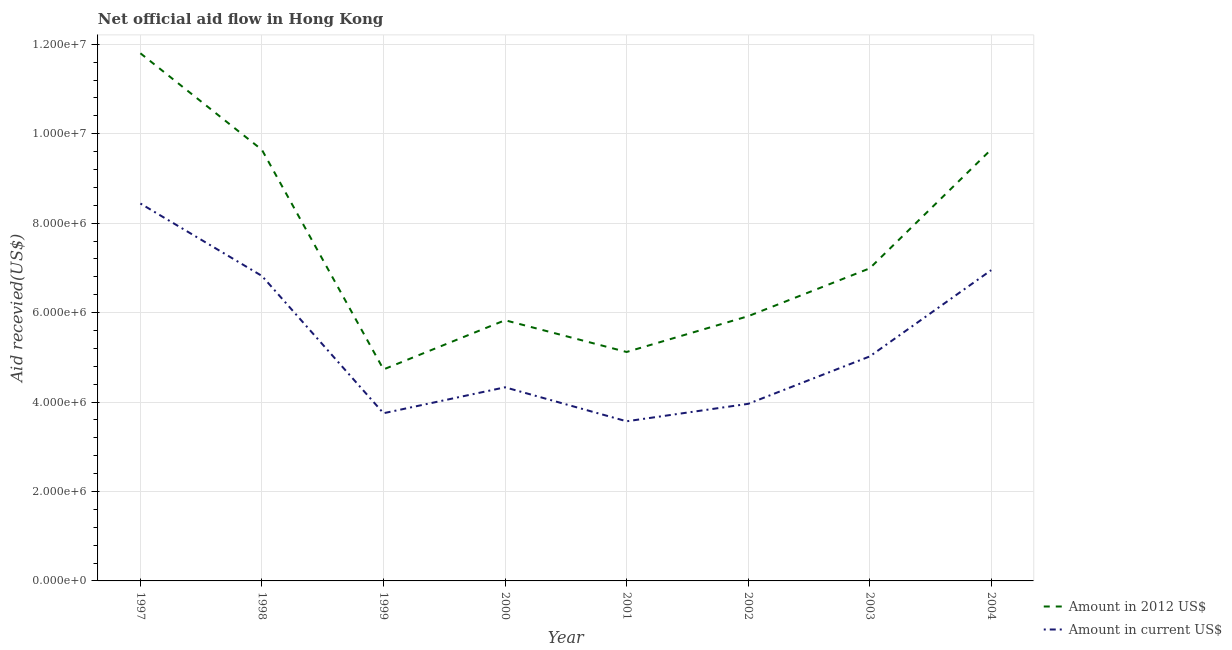What is the amount of aid received(expressed in 2012 us$) in 1998?
Your answer should be compact. 9.64e+06. Across all years, what is the maximum amount of aid received(expressed in 2012 us$)?
Your answer should be very brief. 1.18e+07. Across all years, what is the minimum amount of aid received(expressed in us$)?
Give a very brief answer. 3.57e+06. In which year was the amount of aid received(expressed in us$) maximum?
Your answer should be very brief. 1997. In which year was the amount of aid received(expressed in us$) minimum?
Provide a succinct answer. 2001. What is the total amount of aid received(expressed in 2012 us$) in the graph?
Ensure brevity in your answer.  5.97e+07. What is the difference between the amount of aid received(expressed in 2012 us$) in 1997 and that in 2002?
Keep it short and to the point. 5.88e+06. What is the difference between the amount of aid received(expressed in 2012 us$) in 1999 and the amount of aid received(expressed in us$) in 2002?
Keep it short and to the point. 7.70e+05. What is the average amount of aid received(expressed in 2012 us$) per year?
Ensure brevity in your answer.  7.46e+06. In the year 1999, what is the difference between the amount of aid received(expressed in us$) and amount of aid received(expressed in 2012 us$)?
Make the answer very short. -9.80e+05. In how many years, is the amount of aid received(expressed in us$) greater than 11600000 US$?
Make the answer very short. 0. What is the ratio of the amount of aid received(expressed in 2012 us$) in 2001 to that in 2003?
Provide a succinct answer. 0.73. Is the amount of aid received(expressed in us$) in 2001 less than that in 2002?
Your answer should be very brief. Yes. What is the difference between the highest and the second highest amount of aid received(expressed in 2012 us$)?
Your answer should be compact. 2.15e+06. What is the difference between the highest and the lowest amount of aid received(expressed in us$)?
Offer a terse response. 4.87e+06. Is the sum of the amount of aid received(expressed in us$) in 1997 and 2003 greater than the maximum amount of aid received(expressed in 2012 us$) across all years?
Your answer should be very brief. Yes. Does the amount of aid received(expressed in us$) monotonically increase over the years?
Keep it short and to the point. No. Is the amount of aid received(expressed in 2012 us$) strictly less than the amount of aid received(expressed in us$) over the years?
Offer a terse response. No. How many lines are there?
Give a very brief answer. 2. Are the values on the major ticks of Y-axis written in scientific E-notation?
Make the answer very short. Yes. Does the graph contain any zero values?
Provide a short and direct response. No. What is the title of the graph?
Offer a very short reply. Net official aid flow in Hong Kong. Does "Travel Items" appear as one of the legend labels in the graph?
Keep it short and to the point. No. What is the label or title of the Y-axis?
Offer a very short reply. Aid recevied(US$). What is the Aid recevied(US$) in Amount in 2012 US$ in 1997?
Ensure brevity in your answer.  1.18e+07. What is the Aid recevied(US$) of Amount in current US$ in 1997?
Offer a very short reply. 8.44e+06. What is the Aid recevied(US$) in Amount in 2012 US$ in 1998?
Make the answer very short. 9.64e+06. What is the Aid recevied(US$) in Amount in current US$ in 1998?
Your answer should be very brief. 6.82e+06. What is the Aid recevied(US$) in Amount in 2012 US$ in 1999?
Keep it short and to the point. 4.73e+06. What is the Aid recevied(US$) of Amount in current US$ in 1999?
Ensure brevity in your answer.  3.75e+06. What is the Aid recevied(US$) of Amount in 2012 US$ in 2000?
Your answer should be very brief. 5.83e+06. What is the Aid recevied(US$) in Amount in current US$ in 2000?
Ensure brevity in your answer.  4.33e+06. What is the Aid recevied(US$) in Amount in 2012 US$ in 2001?
Your answer should be very brief. 5.12e+06. What is the Aid recevied(US$) of Amount in current US$ in 2001?
Provide a short and direct response. 3.57e+06. What is the Aid recevied(US$) in Amount in 2012 US$ in 2002?
Your response must be concise. 5.92e+06. What is the Aid recevied(US$) of Amount in current US$ in 2002?
Ensure brevity in your answer.  3.96e+06. What is the Aid recevied(US$) in Amount in 2012 US$ in 2003?
Your response must be concise. 6.99e+06. What is the Aid recevied(US$) in Amount in current US$ in 2003?
Offer a terse response. 5.02e+06. What is the Aid recevied(US$) in Amount in 2012 US$ in 2004?
Keep it short and to the point. 9.65e+06. What is the Aid recevied(US$) in Amount in current US$ in 2004?
Offer a very short reply. 6.95e+06. Across all years, what is the maximum Aid recevied(US$) of Amount in 2012 US$?
Make the answer very short. 1.18e+07. Across all years, what is the maximum Aid recevied(US$) of Amount in current US$?
Give a very brief answer. 8.44e+06. Across all years, what is the minimum Aid recevied(US$) in Amount in 2012 US$?
Keep it short and to the point. 4.73e+06. Across all years, what is the minimum Aid recevied(US$) in Amount in current US$?
Make the answer very short. 3.57e+06. What is the total Aid recevied(US$) of Amount in 2012 US$ in the graph?
Keep it short and to the point. 5.97e+07. What is the total Aid recevied(US$) in Amount in current US$ in the graph?
Offer a very short reply. 4.28e+07. What is the difference between the Aid recevied(US$) of Amount in 2012 US$ in 1997 and that in 1998?
Your answer should be very brief. 2.16e+06. What is the difference between the Aid recevied(US$) in Amount in current US$ in 1997 and that in 1998?
Keep it short and to the point. 1.62e+06. What is the difference between the Aid recevied(US$) of Amount in 2012 US$ in 1997 and that in 1999?
Keep it short and to the point. 7.07e+06. What is the difference between the Aid recevied(US$) in Amount in current US$ in 1997 and that in 1999?
Your answer should be very brief. 4.69e+06. What is the difference between the Aid recevied(US$) in Amount in 2012 US$ in 1997 and that in 2000?
Provide a short and direct response. 5.97e+06. What is the difference between the Aid recevied(US$) in Amount in current US$ in 1997 and that in 2000?
Provide a succinct answer. 4.11e+06. What is the difference between the Aid recevied(US$) in Amount in 2012 US$ in 1997 and that in 2001?
Make the answer very short. 6.68e+06. What is the difference between the Aid recevied(US$) of Amount in current US$ in 1997 and that in 2001?
Your answer should be compact. 4.87e+06. What is the difference between the Aid recevied(US$) in Amount in 2012 US$ in 1997 and that in 2002?
Your answer should be very brief. 5.88e+06. What is the difference between the Aid recevied(US$) in Amount in current US$ in 1997 and that in 2002?
Your answer should be compact. 4.48e+06. What is the difference between the Aid recevied(US$) of Amount in 2012 US$ in 1997 and that in 2003?
Offer a terse response. 4.81e+06. What is the difference between the Aid recevied(US$) of Amount in current US$ in 1997 and that in 2003?
Make the answer very short. 3.42e+06. What is the difference between the Aid recevied(US$) in Amount in 2012 US$ in 1997 and that in 2004?
Make the answer very short. 2.15e+06. What is the difference between the Aid recevied(US$) in Amount in current US$ in 1997 and that in 2004?
Make the answer very short. 1.49e+06. What is the difference between the Aid recevied(US$) in Amount in 2012 US$ in 1998 and that in 1999?
Keep it short and to the point. 4.91e+06. What is the difference between the Aid recevied(US$) of Amount in current US$ in 1998 and that in 1999?
Make the answer very short. 3.07e+06. What is the difference between the Aid recevied(US$) in Amount in 2012 US$ in 1998 and that in 2000?
Give a very brief answer. 3.81e+06. What is the difference between the Aid recevied(US$) in Amount in current US$ in 1998 and that in 2000?
Your response must be concise. 2.49e+06. What is the difference between the Aid recevied(US$) in Amount in 2012 US$ in 1998 and that in 2001?
Keep it short and to the point. 4.52e+06. What is the difference between the Aid recevied(US$) in Amount in current US$ in 1998 and that in 2001?
Provide a succinct answer. 3.25e+06. What is the difference between the Aid recevied(US$) of Amount in 2012 US$ in 1998 and that in 2002?
Provide a succinct answer. 3.72e+06. What is the difference between the Aid recevied(US$) in Amount in current US$ in 1998 and that in 2002?
Your response must be concise. 2.86e+06. What is the difference between the Aid recevied(US$) of Amount in 2012 US$ in 1998 and that in 2003?
Offer a terse response. 2.65e+06. What is the difference between the Aid recevied(US$) of Amount in current US$ in 1998 and that in 2003?
Offer a terse response. 1.80e+06. What is the difference between the Aid recevied(US$) of Amount in 2012 US$ in 1999 and that in 2000?
Your answer should be very brief. -1.10e+06. What is the difference between the Aid recevied(US$) in Amount in current US$ in 1999 and that in 2000?
Your answer should be very brief. -5.80e+05. What is the difference between the Aid recevied(US$) in Amount in 2012 US$ in 1999 and that in 2001?
Offer a terse response. -3.90e+05. What is the difference between the Aid recevied(US$) in Amount in 2012 US$ in 1999 and that in 2002?
Make the answer very short. -1.19e+06. What is the difference between the Aid recevied(US$) in Amount in current US$ in 1999 and that in 2002?
Give a very brief answer. -2.10e+05. What is the difference between the Aid recevied(US$) of Amount in 2012 US$ in 1999 and that in 2003?
Keep it short and to the point. -2.26e+06. What is the difference between the Aid recevied(US$) in Amount in current US$ in 1999 and that in 2003?
Your response must be concise. -1.27e+06. What is the difference between the Aid recevied(US$) in Amount in 2012 US$ in 1999 and that in 2004?
Offer a terse response. -4.92e+06. What is the difference between the Aid recevied(US$) in Amount in current US$ in 1999 and that in 2004?
Give a very brief answer. -3.20e+06. What is the difference between the Aid recevied(US$) in Amount in 2012 US$ in 2000 and that in 2001?
Offer a very short reply. 7.10e+05. What is the difference between the Aid recevied(US$) in Amount in current US$ in 2000 and that in 2001?
Ensure brevity in your answer.  7.60e+05. What is the difference between the Aid recevied(US$) in Amount in 2012 US$ in 2000 and that in 2002?
Ensure brevity in your answer.  -9.00e+04. What is the difference between the Aid recevied(US$) of Amount in current US$ in 2000 and that in 2002?
Offer a very short reply. 3.70e+05. What is the difference between the Aid recevied(US$) of Amount in 2012 US$ in 2000 and that in 2003?
Provide a short and direct response. -1.16e+06. What is the difference between the Aid recevied(US$) of Amount in current US$ in 2000 and that in 2003?
Your answer should be compact. -6.90e+05. What is the difference between the Aid recevied(US$) of Amount in 2012 US$ in 2000 and that in 2004?
Your answer should be compact. -3.82e+06. What is the difference between the Aid recevied(US$) of Amount in current US$ in 2000 and that in 2004?
Offer a very short reply. -2.62e+06. What is the difference between the Aid recevied(US$) in Amount in 2012 US$ in 2001 and that in 2002?
Make the answer very short. -8.00e+05. What is the difference between the Aid recevied(US$) of Amount in current US$ in 2001 and that in 2002?
Ensure brevity in your answer.  -3.90e+05. What is the difference between the Aid recevied(US$) of Amount in 2012 US$ in 2001 and that in 2003?
Your answer should be compact. -1.87e+06. What is the difference between the Aid recevied(US$) of Amount in current US$ in 2001 and that in 2003?
Your answer should be compact. -1.45e+06. What is the difference between the Aid recevied(US$) in Amount in 2012 US$ in 2001 and that in 2004?
Your answer should be very brief. -4.53e+06. What is the difference between the Aid recevied(US$) in Amount in current US$ in 2001 and that in 2004?
Make the answer very short. -3.38e+06. What is the difference between the Aid recevied(US$) of Amount in 2012 US$ in 2002 and that in 2003?
Offer a terse response. -1.07e+06. What is the difference between the Aid recevied(US$) in Amount in current US$ in 2002 and that in 2003?
Your answer should be compact. -1.06e+06. What is the difference between the Aid recevied(US$) of Amount in 2012 US$ in 2002 and that in 2004?
Keep it short and to the point. -3.73e+06. What is the difference between the Aid recevied(US$) of Amount in current US$ in 2002 and that in 2004?
Offer a very short reply. -2.99e+06. What is the difference between the Aid recevied(US$) of Amount in 2012 US$ in 2003 and that in 2004?
Ensure brevity in your answer.  -2.66e+06. What is the difference between the Aid recevied(US$) in Amount in current US$ in 2003 and that in 2004?
Your answer should be compact. -1.93e+06. What is the difference between the Aid recevied(US$) of Amount in 2012 US$ in 1997 and the Aid recevied(US$) of Amount in current US$ in 1998?
Offer a very short reply. 4.98e+06. What is the difference between the Aid recevied(US$) in Amount in 2012 US$ in 1997 and the Aid recevied(US$) in Amount in current US$ in 1999?
Provide a short and direct response. 8.05e+06. What is the difference between the Aid recevied(US$) of Amount in 2012 US$ in 1997 and the Aid recevied(US$) of Amount in current US$ in 2000?
Make the answer very short. 7.47e+06. What is the difference between the Aid recevied(US$) in Amount in 2012 US$ in 1997 and the Aid recevied(US$) in Amount in current US$ in 2001?
Offer a very short reply. 8.23e+06. What is the difference between the Aid recevied(US$) of Amount in 2012 US$ in 1997 and the Aid recevied(US$) of Amount in current US$ in 2002?
Ensure brevity in your answer.  7.84e+06. What is the difference between the Aid recevied(US$) of Amount in 2012 US$ in 1997 and the Aid recevied(US$) of Amount in current US$ in 2003?
Your answer should be compact. 6.78e+06. What is the difference between the Aid recevied(US$) of Amount in 2012 US$ in 1997 and the Aid recevied(US$) of Amount in current US$ in 2004?
Ensure brevity in your answer.  4.85e+06. What is the difference between the Aid recevied(US$) of Amount in 2012 US$ in 1998 and the Aid recevied(US$) of Amount in current US$ in 1999?
Keep it short and to the point. 5.89e+06. What is the difference between the Aid recevied(US$) in Amount in 2012 US$ in 1998 and the Aid recevied(US$) in Amount in current US$ in 2000?
Your answer should be very brief. 5.31e+06. What is the difference between the Aid recevied(US$) of Amount in 2012 US$ in 1998 and the Aid recevied(US$) of Amount in current US$ in 2001?
Offer a very short reply. 6.07e+06. What is the difference between the Aid recevied(US$) of Amount in 2012 US$ in 1998 and the Aid recevied(US$) of Amount in current US$ in 2002?
Provide a succinct answer. 5.68e+06. What is the difference between the Aid recevied(US$) of Amount in 2012 US$ in 1998 and the Aid recevied(US$) of Amount in current US$ in 2003?
Give a very brief answer. 4.62e+06. What is the difference between the Aid recevied(US$) of Amount in 2012 US$ in 1998 and the Aid recevied(US$) of Amount in current US$ in 2004?
Provide a short and direct response. 2.69e+06. What is the difference between the Aid recevied(US$) in Amount in 2012 US$ in 1999 and the Aid recevied(US$) in Amount in current US$ in 2001?
Make the answer very short. 1.16e+06. What is the difference between the Aid recevied(US$) of Amount in 2012 US$ in 1999 and the Aid recevied(US$) of Amount in current US$ in 2002?
Provide a succinct answer. 7.70e+05. What is the difference between the Aid recevied(US$) of Amount in 2012 US$ in 1999 and the Aid recevied(US$) of Amount in current US$ in 2003?
Your answer should be compact. -2.90e+05. What is the difference between the Aid recevied(US$) of Amount in 2012 US$ in 1999 and the Aid recevied(US$) of Amount in current US$ in 2004?
Your answer should be very brief. -2.22e+06. What is the difference between the Aid recevied(US$) in Amount in 2012 US$ in 2000 and the Aid recevied(US$) in Amount in current US$ in 2001?
Provide a short and direct response. 2.26e+06. What is the difference between the Aid recevied(US$) of Amount in 2012 US$ in 2000 and the Aid recevied(US$) of Amount in current US$ in 2002?
Offer a terse response. 1.87e+06. What is the difference between the Aid recevied(US$) of Amount in 2012 US$ in 2000 and the Aid recevied(US$) of Amount in current US$ in 2003?
Offer a very short reply. 8.10e+05. What is the difference between the Aid recevied(US$) in Amount in 2012 US$ in 2000 and the Aid recevied(US$) in Amount in current US$ in 2004?
Your answer should be very brief. -1.12e+06. What is the difference between the Aid recevied(US$) of Amount in 2012 US$ in 2001 and the Aid recevied(US$) of Amount in current US$ in 2002?
Provide a short and direct response. 1.16e+06. What is the difference between the Aid recevied(US$) in Amount in 2012 US$ in 2001 and the Aid recevied(US$) in Amount in current US$ in 2004?
Keep it short and to the point. -1.83e+06. What is the difference between the Aid recevied(US$) of Amount in 2012 US$ in 2002 and the Aid recevied(US$) of Amount in current US$ in 2004?
Ensure brevity in your answer.  -1.03e+06. What is the difference between the Aid recevied(US$) in Amount in 2012 US$ in 2003 and the Aid recevied(US$) in Amount in current US$ in 2004?
Your answer should be compact. 4.00e+04. What is the average Aid recevied(US$) of Amount in 2012 US$ per year?
Give a very brief answer. 7.46e+06. What is the average Aid recevied(US$) in Amount in current US$ per year?
Offer a very short reply. 5.36e+06. In the year 1997, what is the difference between the Aid recevied(US$) of Amount in 2012 US$ and Aid recevied(US$) of Amount in current US$?
Offer a terse response. 3.36e+06. In the year 1998, what is the difference between the Aid recevied(US$) of Amount in 2012 US$ and Aid recevied(US$) of Amount in current US$?
Give a very brief answer. 2.82e+06. In the year 1999, what is the difference between the Aid recevied(US$) of Amount in 2012 US$ and Aid recevied(US$) of Amount in current US$?
Your answer should be very brief. 9.80e+05. In the year 2000, what is the difference between the Aid recevied(US$) of Amount in 2012 US$ and Aid recevied(US$) of Amount in current US$?
Give a very brief answer. 1.50e+06. In the year 2001, what is the difference between the Aid recevied(US$) in Amount in 2012 US$ and Aid recevied(US$) in Amount in current US$?
Make the answer very short. 1.55e+06. In the year 2002, what is the difference between the Aid recevied(US$) in Amount in 2012 US$ and Aid recevied(US$) in Amount in current US$?
Offer a very short reply. 1.96e+06. In the year 2003, what is the difference between the Aid recevied(US$) in Amount in 2012 US$ and Aid recevied(US$) in Amount in current US$?
Provide a short and direct response. 1.97e+06. In the year 2004, what is the difference between the Aid recevied(US$) of Amount in 2012 US$ and Aid recevied(US$) of Amount in current US$?
Make the answer very short. 2.70e+06. What is the ratio of the Aid recevied(US$) in Amount in 2012 US$ in 1997 to that in 1998?
Make the answer very short. 1.22. What is the ratio of the Aid recevied(US$) of Amount in current US$ in 1997 to that in 1998?
Offer a very short reply. 1.24. What is the ratio of the Aid recevied(US$) in Amount in 2012 US$ in 1997 to that in 1999?
Offer a very short reply. 2.49. What is the ratio of the Aid recevied(US$) of Amount in current US$ in 1997 to that in 1999?
Provide a succinct answer. 2.25. What is the ratio of the Aid recevied(US$) of Amount in 2012 US$ in 1997 to that in 2000?
Your response must be concise. 2.02. What is the ratio of the Aid recevied(US$) in Amount in current US$ in 1997 to that in 2000?
Offer a terse response. 1.95. What is the ratio of the Aid recevied(US$) of Amount in 2012 US$ in 1997 to that in 2001?
Offer a terse response. 2.3. What is the ratio of the Aid recevied(US$) of Amount in current US$ in 1997 to that in 2001?
Your answer should be compact. 2.36. What is the ratio of the Aid recevied(US$) in Amount in 2012 US$ in 1997 to that in 2002?
Your response must be concise. 1.99. What is the ratio of the Aid recevied(US$) of Amount in current US$ in 1997 to that in 2002?
Make the answer very short. 2.13. What is the ratio of the Aid recevied(US$) of Amount in 2012 US$ in 1997 to that in 2003?
Provide a succinct answer. 1.69. What is the ratio of the Aid recevied(US$) in Amount in current US$ in 1997 to that in 2003?
Your answer should be very brief. 1.68. What is the ratio of the Aid recevied(US$) of Amount in 2012 US$ in 1997 to that in 2004?
Ensure brevity in your answer.  1.22. What is the ratio of the Aid recevied(US$) of Amount in current US$ in 1997 to that in 2004?
Provide a succinct answer. 1.21. What is the ratio of the Aid recevied(US$) in Amount in 2012 US$ in 1998 to that in 1999?
Make the answer very short. 2.04. What is the ratio of the Aid recevied(US$) of Amount in current US$ in 1998 to that in 1999?
Offer a very short reply. 1.82. What is the ratio of the Aid recevied(US$) in Amount in 2012 US$ in 1998 to that in 2000?
Keep it short and to the point. 1.65. What is the ratio of the Aid recevied(US$) in Amount in current US$ in 1998 to that in 2000?
Your answer should be very brief. 1.58. What is the ratio of the Aid recevied(US$) of Amount in 2012 US$ in 1998 to that in 2001?
Make the answer very short. 1.88. What is the ratio of the Aid recevied(US$) in Amount in current US$ in 1998 to that in 2001?
Provide a short and direct response. 1.91. What is the ratio of the Aid recevied(US$) in Amount in 2012 US$ in 1998 to that in 2002?
Provide a short and direct response. 1.63. What is the ratio of the Aid recevied(US$) of Amount in current US$ in 1998 to that in 2002?
Make the answer very short. 1.72. What is the ratio of the Aid recevied(US$) in Amount in 2012 US$ in 1998 to that in 2003?
Offer a very short reply. 1.38. What is the ratio of the Aid recevied(US$) of Amount in current US$ in 1998 to that in 2003?
Offer a terse response. 1.36. What is the ratio of the Aid recevied(US$) in Amount in current US$ in 1998 to that in 2004?
Your answer should be very brief. 0.98. What is the ratio of the Aid recevied(US$) of Amount in 2012 US$ in 1999 to that in 2000?
Give a very brief answer. 0.81. What is the ratio of the Aid recevied(US$) of Amount in current US$ in 1999 to that in 2000?
Give a very brief answer. 0.87. What is the ratio of the Aid recevied(US$) of Amount in 2012 US$ in 1999 to that in 2001?
Your answer should be very brief. 0.92. What is the ratio of the Aid recevied(US$) of Amount in current US$ in 1999 to that in 2001?
Your answer should be very brief. 1.05. What is the ratio of the Aid recevied(US$) in Amount in 2012 US$ in 1999 to that in 2002?
Provide a succinct answer. 0.8. What is the ratio of the Aid recevied(US$) in Amount in current US$ in 1999 to that in 2002?
Offer a very short reply. 0.95. What is the ratio of the Aid recevied(US$) of Amount in 2012 US$ in 1999 to that in 2003?
Provide a succinct answer. 0.68. What is the ratio of the Aid recevied(US$) in Amount in current US$ in 1999 to that in 2003?
Your response must be concise. 0.75. What is the ratio of the Aid recevied(US$) of Amount in 2012 US$ in 1999 to that in 2004?
Your answer should be very brief. 0.49. What is the ratio of the Aid recevied(US$) of Amount in current US$ in 1999 to that in 2004?
Provide a short and direct response. 0.54. What is the ratio of the Aid recevied(US$) of Amount in 2012 US$ in 2000 to that in 2001?
Make the answer very short. 1.14. What is the ratio of the Aid recevied(US$) in Amount in current US$ in 2000 to that in 2001?
Give a very brief answer. 1.21. What is the ratio of the Aid recevied(US$) of Amount in 2012 US$ in 2000 to that in 2002?
Ensure brevity in your answer.  0.98. What is the ratio of the Aid recevied(US$) in Amount in current US$ in 2000 to that in 2002?
Make the answer very short. 1.09. What is the ratio of the Aid recevied(US$) in Amount in 2012 US$ in 2000 to that in 2003?
Your answer should be very brief. 0.83. What is the ratio of the Aid recevied(US$) of Amount in current US$ in 2000 to that in 2003?
Offer a terse response. 0.86. What is the ratio of the Aid recevied(US$) in Amount in 2012 US$ in 2000 to that in 2004?
Give a very brief answer. 0.6. What is the ratio of the Aid recevied(US$) of Amount in current US$ in 2000 to that in 2004?
Provide a short and direct response. 0.62. What is the ratio of the Aid recevied(US$) of Amount in 2012 US$ in 2001 to that in 2002?
Ensure brevity in your answer.  0.86. What is the ratio of the Aid recevied(US$) of Amount in current US$ in 2001 to that in 2002?
Offer a terse response. 0.9. What is the ratio of the Aid recevied(US$) in Amount in 2012 US$ in 2001 to that in 2003?
Make the answer very short. 0.73. What is the ratio of the Aid recevied(US$) of Amount in current US$ in 2001 to that in 2003?
Your answer should be very brief. 0.71. What is the ratio of the Aid recevied(US$) in Amount in 2012 US$ in 2001 to that in 2004?
Offer a terse response. 0.53. What is the ratio of the Aid recevied(US$) in Amount in current US$ in 2001 to that in 2004?
Make the answer very short. 0.51. What is the ratio of the Aid recevied(US$) in Amount in 2012 US$ in 2002 to that in 2003?
Your response must be concise. 0.85. What is the ratio of the Aid recevied(US$) of Amount in current US$ in 2002 to that in 2003?
Provide a succinct answer. 0.79. What is the ratio of the Aid recevied(US$) of Amount in 2012 US$ in 2002 to that in 2004?
Provide a short and direct response. 0.61. What is the ratio of the Aid recevied(US$) of Amount in current US$ in 2002 to that in 2004?
Your answer should be compact. 0.57. What is the ratio of the Aid recevied(US$) of Amount in 2012 US$ in 2003 to that in 2004?
Keep it short and to the point. 0.72. What is the ratio of the Aid recevied(US$) of Amount in current US$ in 2003 to that in 2004?
Give a very brief answer. 0.72. What is the difference between the highest and the second highest Aid recevied(US$) of Amount in 2012 US$?
Keep it short and to the point. 2.15e+06. What is the difference between the highest and the second highest Aid recevied(US$) in Amount in current US$?
Keep it short and to the point. 1.49e+06. What is the difference between the highest and the lowest Aid recevied(US$) of Amount in 2012 US$?
Offer a terse response. 7.07e+06. What is the difference between the highest and the lowest Aid recevied(US$) of Amount in current US$?
Make the answer very short. 4.87e+06. 